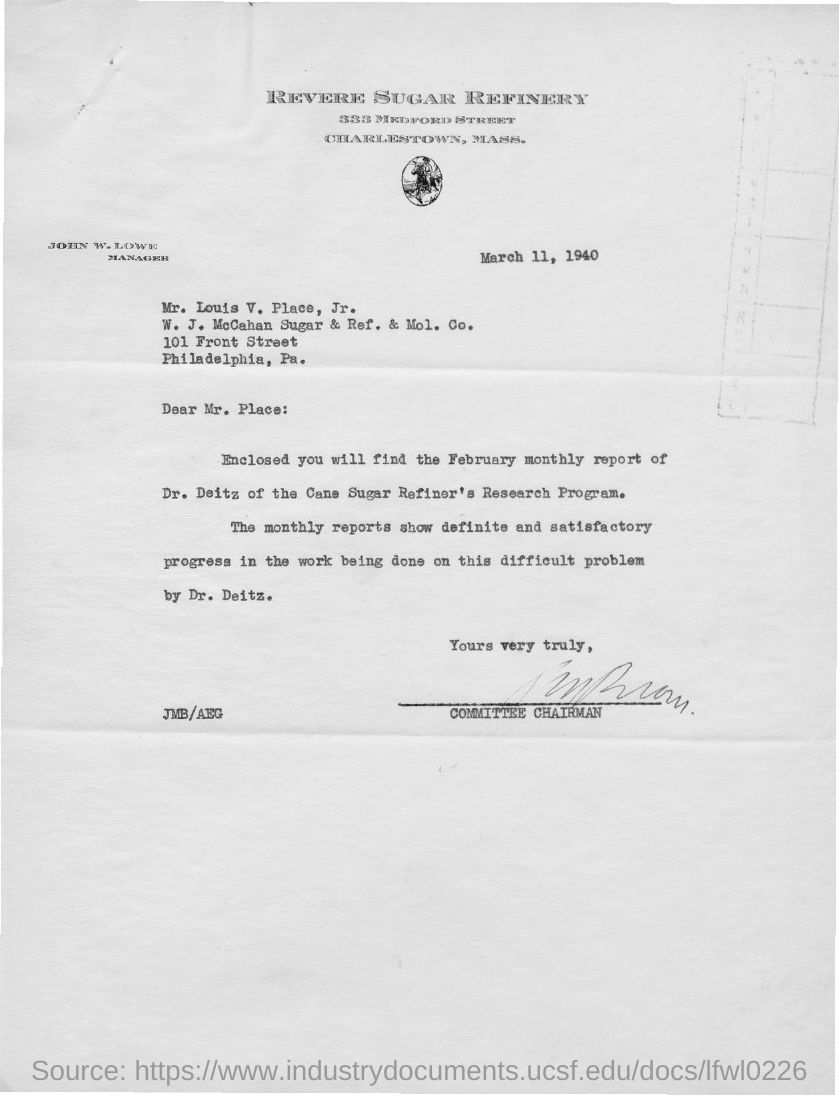What is the date on the document?
Your response must be concise. March 11, 1940. To Whom is this letter addressed to?
Offer a very short reply. Mr. Louis V. Place, Jr. Whose report is enclosed?
Make the answer very short. Dr. Deitz. 